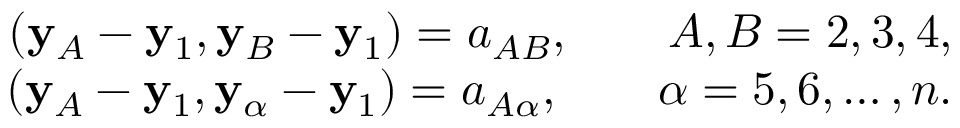<formula> <loc_0><loc_0><loc_500><loc_500>\begin{array} { r } { ( { y } _ { A } - { y } _ { 1 } , { y } _ { B } - { y } _ { 1 } ) = a _ { A B } , \quad A , B = 2 , 3 , 4 , } \\ { ( { y } _ { A } - { y } _ { 1 } , { y } _ { \alpha } - { y } _ { 1 } ) = a _ { A \alpha } , \quad \alpha = 5 , 6 , \dots , n . } \end{array}</formula> 